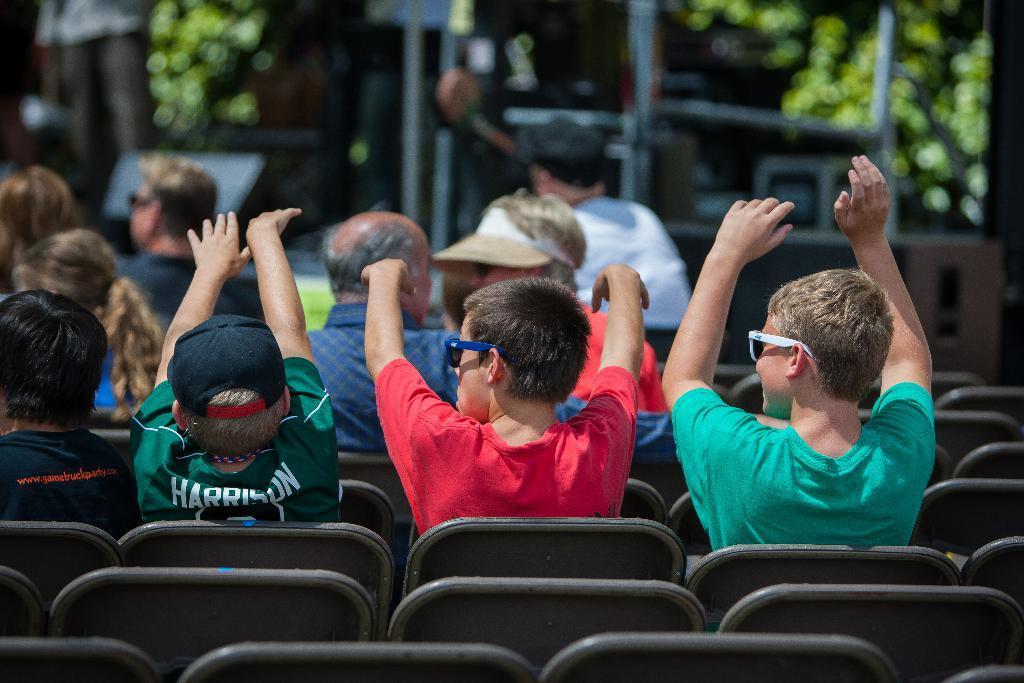Please provide a concise description of this image. In the picture we can see group of people sitting on chairs, some are raising their hands and in the background picture is blur. 